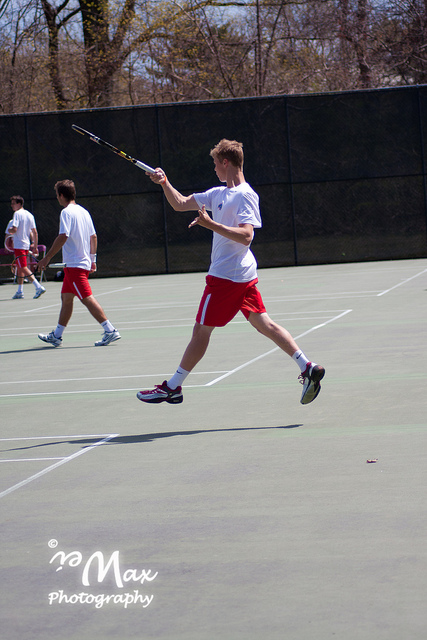How many people are in the picture? The picture captures two individuals actively playing tennis on a court. 